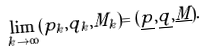Convert formula to latex. <formula><loc_0><loc_0><loc_500><loc_500>\lim _ { k \to \infty } ( p _ { k } , q _ { k } , M _ { k } ) = ( \underline { p } , \underline { q } , \underline { M } ) .</formula> 